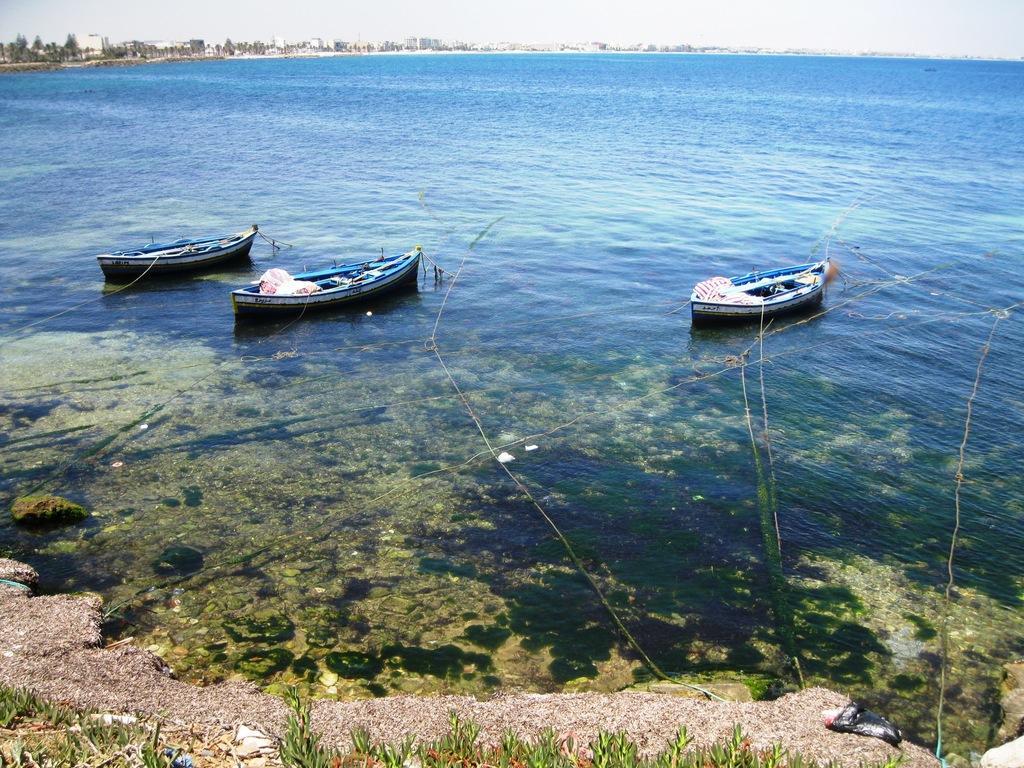In one or two sentences, can you explain what this image depicts? In this picture there are ships on the water in the image and there is grass land at the bottom side of the image and there is water around the area of the image, there are trees and buildings at the top side of the image. 